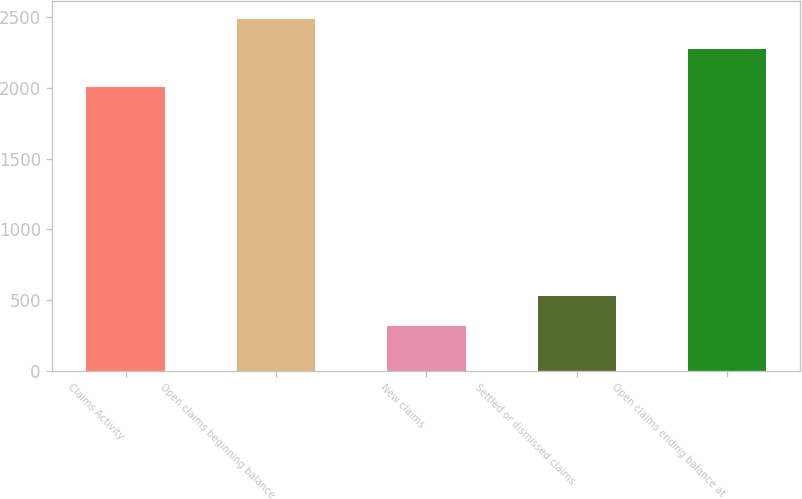Convert chart. <chart><loc_0><loc_0><loc_500><loc_500><bar_chart><fcel>Claims Activity<fcel>Open claims beginning balance<fcel>New claims<fcel>Settled or dismissed claims<fcel>Open claims ending balance at<nl><fcel>2006<fcel>2488.9<fcel>316<fcel>527.9<fcel>2277<nl></chart> 